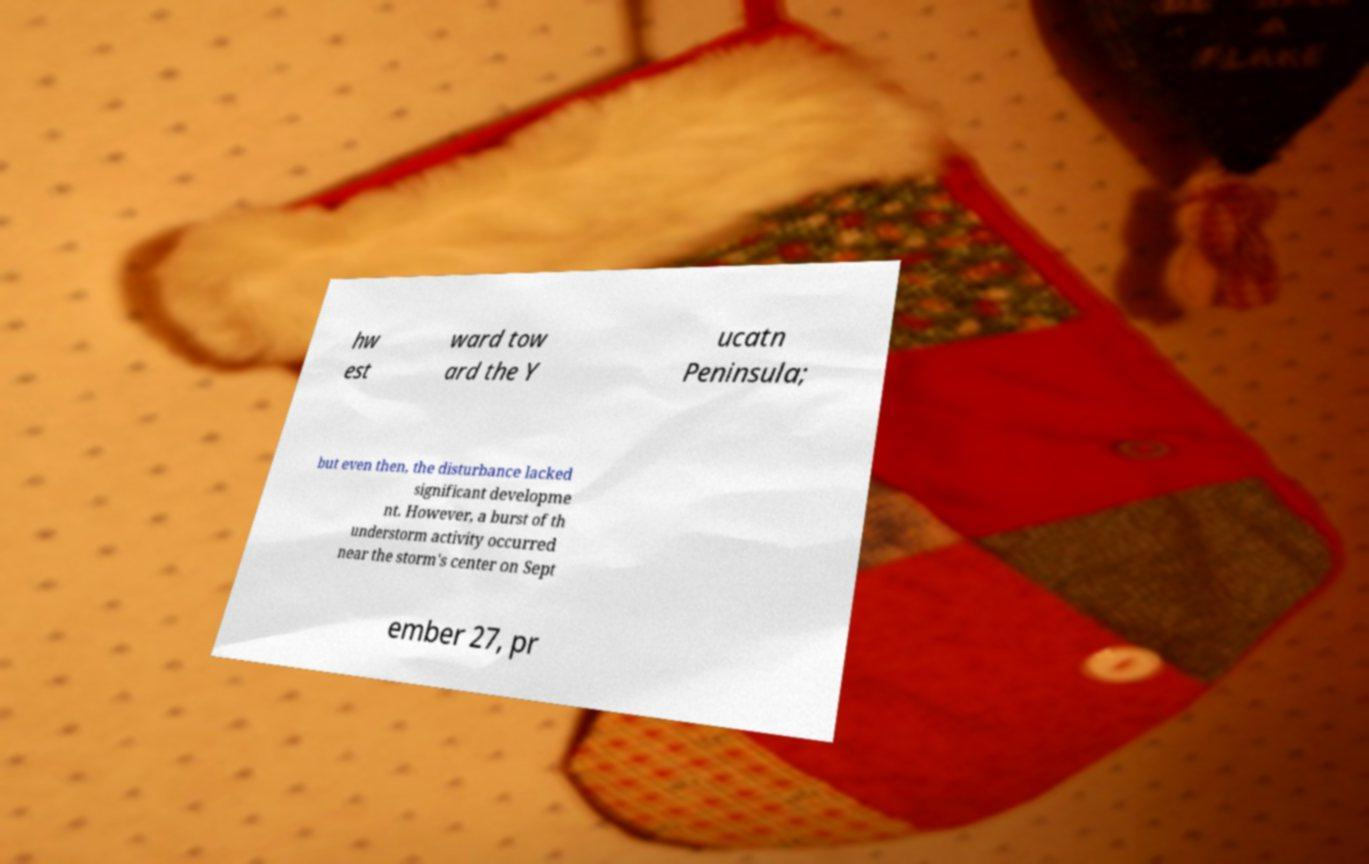What messages or text are displayed in this image? I need them in a readable, typed format. hw est ward tow ard the Y ucatn Peninsula; but even then, the disturbance lacked significant developme nt. However, a burst of th understorm activity occurred near the storm's center on Sept ember 27, pr 